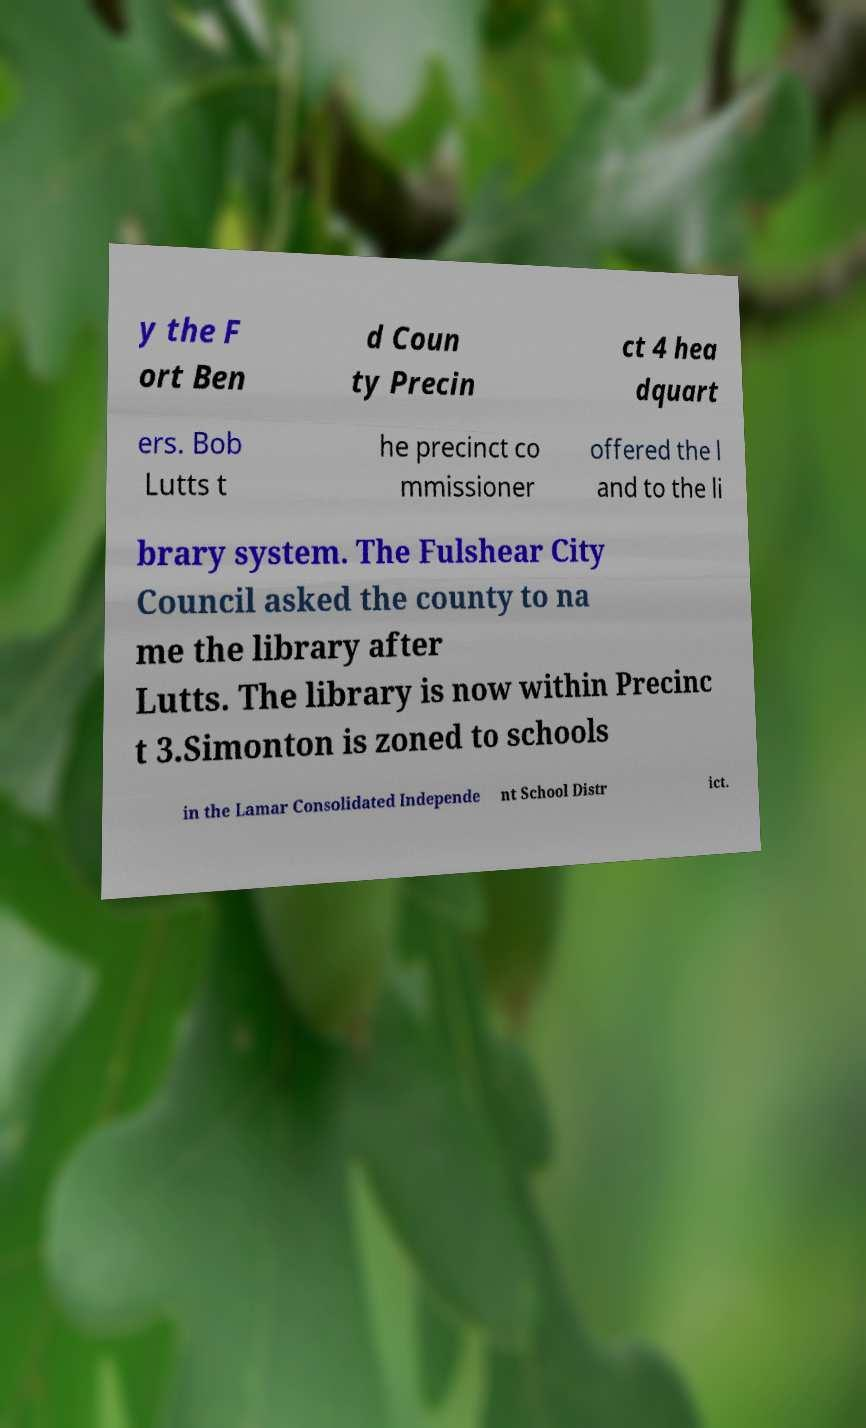Could you assist in decoding the text presented in this image and type it out clearly? y the F ort Ben d Coun ty Precin ct 4 hea dquart ers. Bob Lutts t he precinct co mmissioner offered the l and to the li brary system. The Fulshear City Council asked the county to na me the library after Lutts. The library is now within Precinc t 3.Simonton is zoned to schools in the Lamar Consolidated Independe nt School Distr ict. 